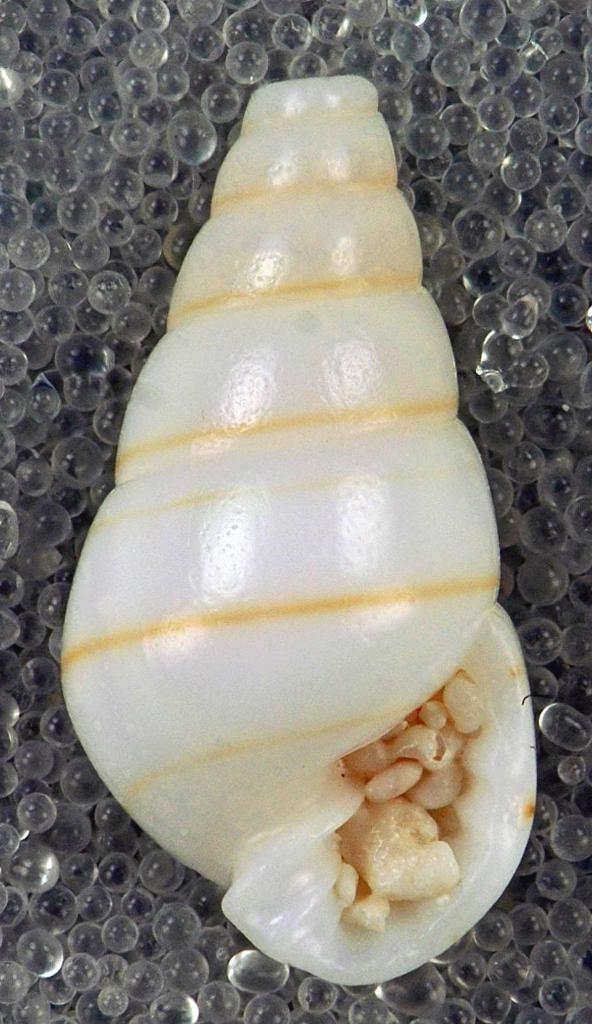What type of objects can be seen in the image? There are sea shells in the image. What are the sea shells placed on? The sea shells are on water balls. What type of haircut is visible on the sea shells in the image? There is no haircut present on the sea shells in the image, as they are inanimate objects. 